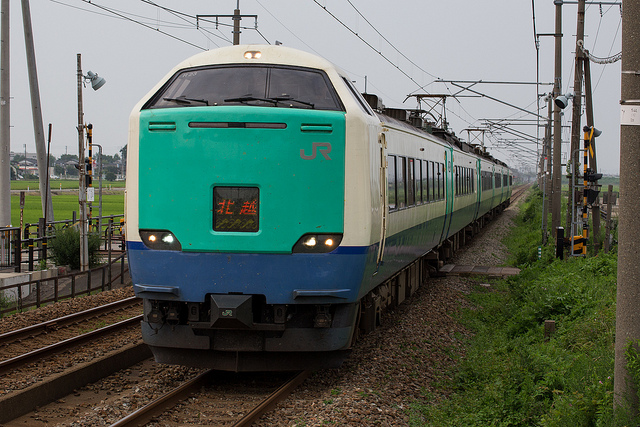<image>Where is this train going? It is unknown where this train is going. Where is this train going? I am not sure where this train is going. It can be going to China, a city, Japan, or Tokyo. 